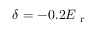<formula> <loc_0><loc_0><loc_500><loc_500>\delta = - 0 . 2 E _ { r }</formula> 